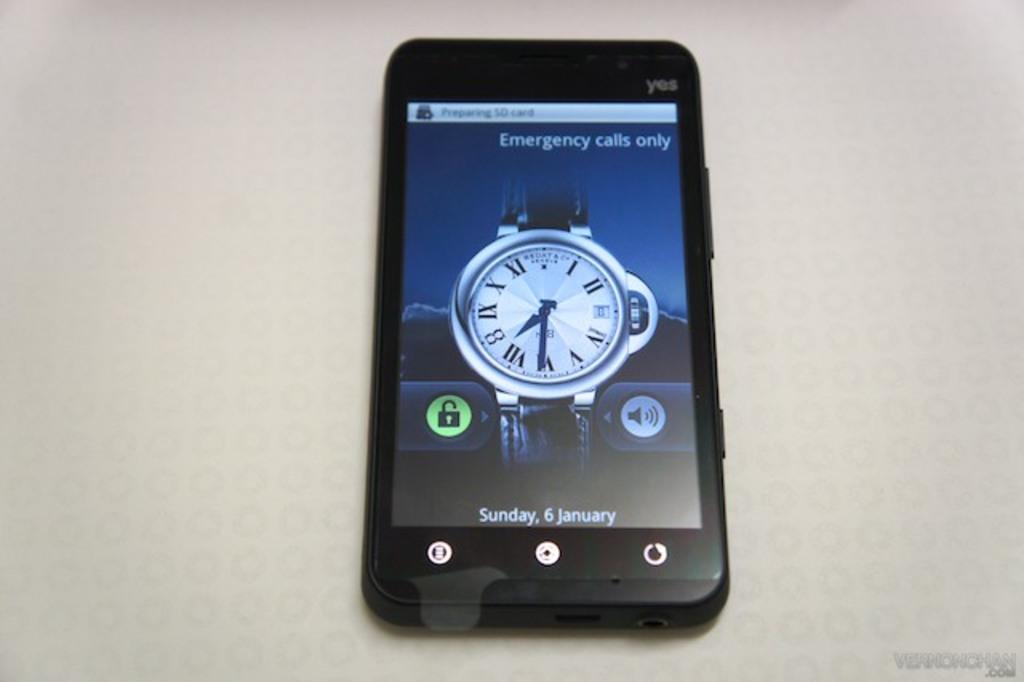What is the date displayed at the bottom?
Provide a short and direct response. Sunday, 6 january. 